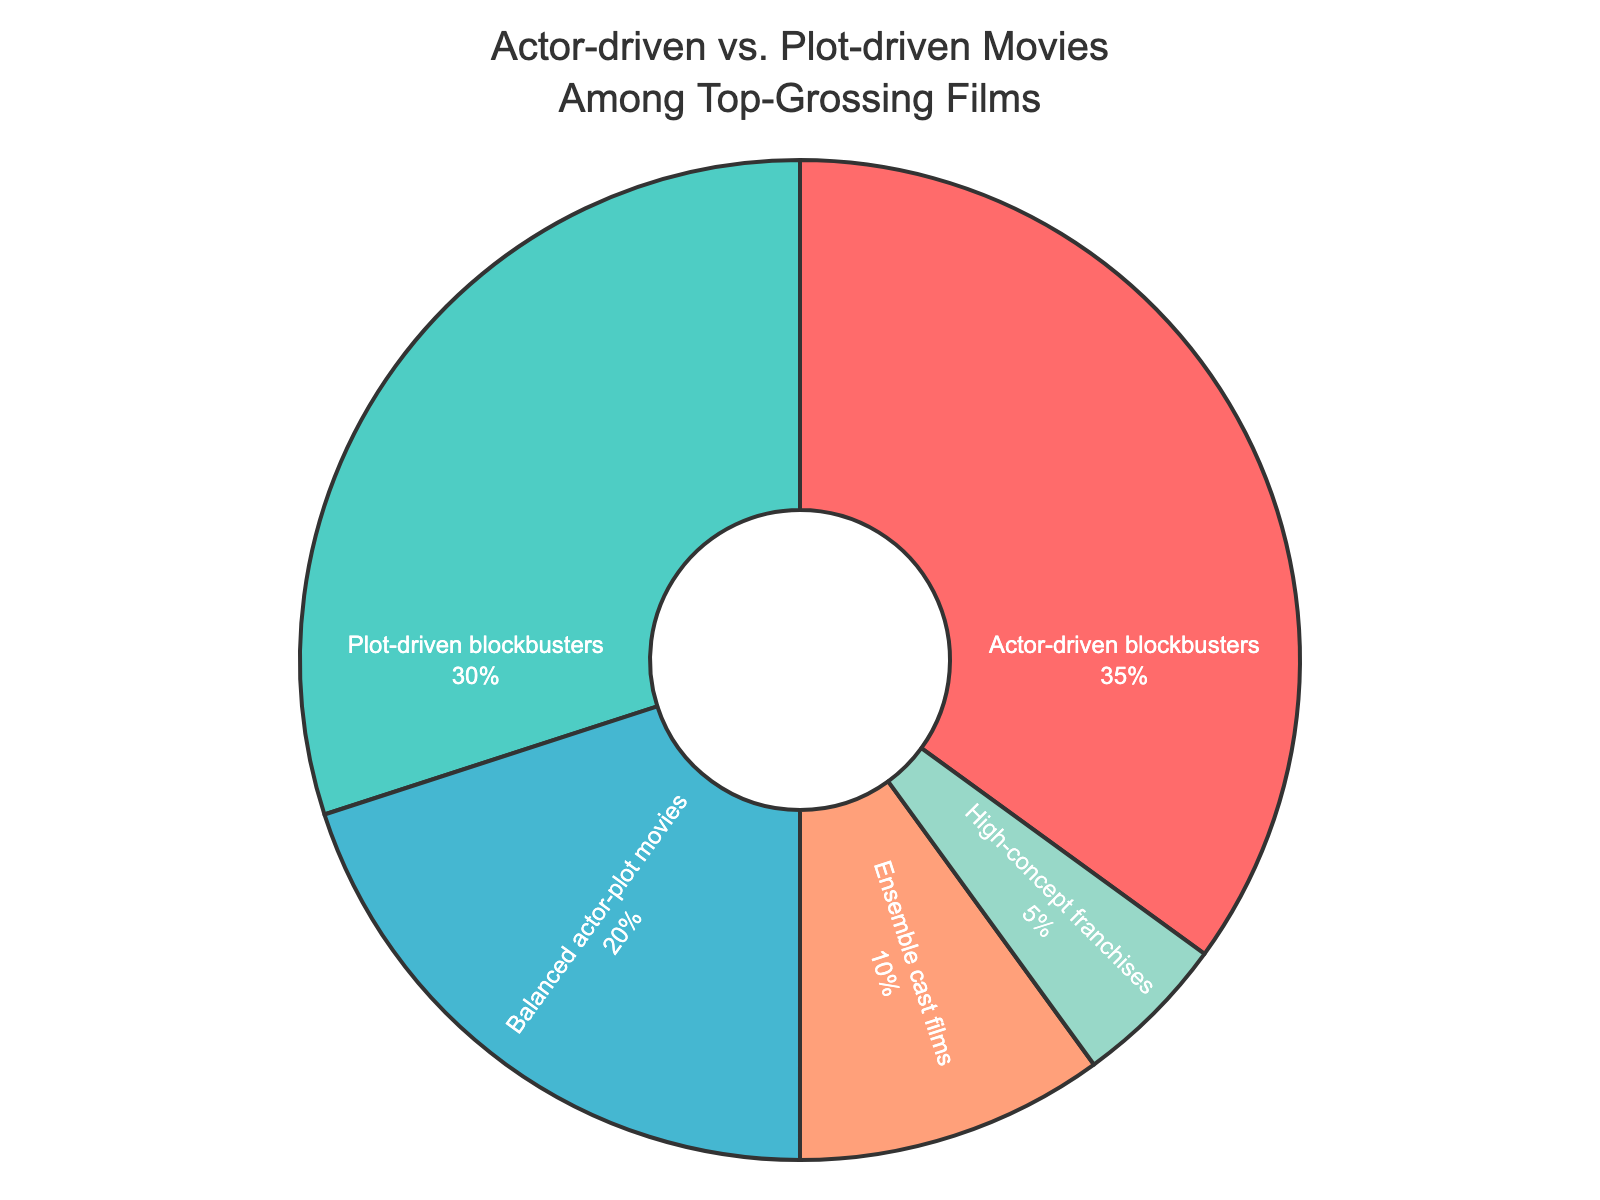What is the percentage of actor-driven blockbusters? By looking at the pie chart, we can see the section labeled "Actor-driven blockbusters" clearly shows a percentage of 35%
Answer: 35% What category has the smallest percentage? Observing the pie chart, the smallest wedge corresponds to "High-concept franchises," denoted by a thin segment that is noticeably smaller than the others
Answer: High-concept franchises What is the difference in percentage between actor-driven and plot-driven blockbusters? From the chart, actor-driven blockbusters are 35% and plot-driven blockbusters are 30%; thus, the difference is calculated as 35% - 30%
Answer: 5% If you combine actor-driven blockbusters and ensemble cast films, what is the total percentage? Adding the percentages from the pie chart for actor-driven blockbusters (35%) and ensemble cast films (10%), we get 35% + 10%
Answer: 45% Which category has a higher percentage: balanced actor-plot movies or plot-driven blockbusters? Comparing the pie chart’s sections, balanced actor-plot movies are 20% while plot-driven blockbusters are 30%, making plot-driven blockbusters higher
Answer: Plot-driven blockbusters What is the combined percentage for balanced actor-plot movies and high-concept franchises? From the pie chart, balanced actor-plot movies are 20% and high-concept franchises are 5%; together they sum up to 20% + 5%
Answer: 25% Which category is represented by the color red in the pie chart? Observing the color used in the pie chart, it’s clear that the red section corresponds to "Actor-driven blockbusters"
Answer: Actor-driven blockbusters How much more do actor-driven blockbusters form compared to ensemble cast films? From the chart, actor-driven blockbusters are 35% and ensemble cast films are 10%. The difference calculated is 35% - 10%
Answer: 25% What three categories together make up exactly 65%? By examining the percentages on the pie chart, the combination of actor-driven blockbusters (35%), plot-driven blockbusters (30%), and high-concept franchises (5%) sums to 65%
Answer: Actor-driven blockbusters, plot-driven blockbusters, high-concept franchises 